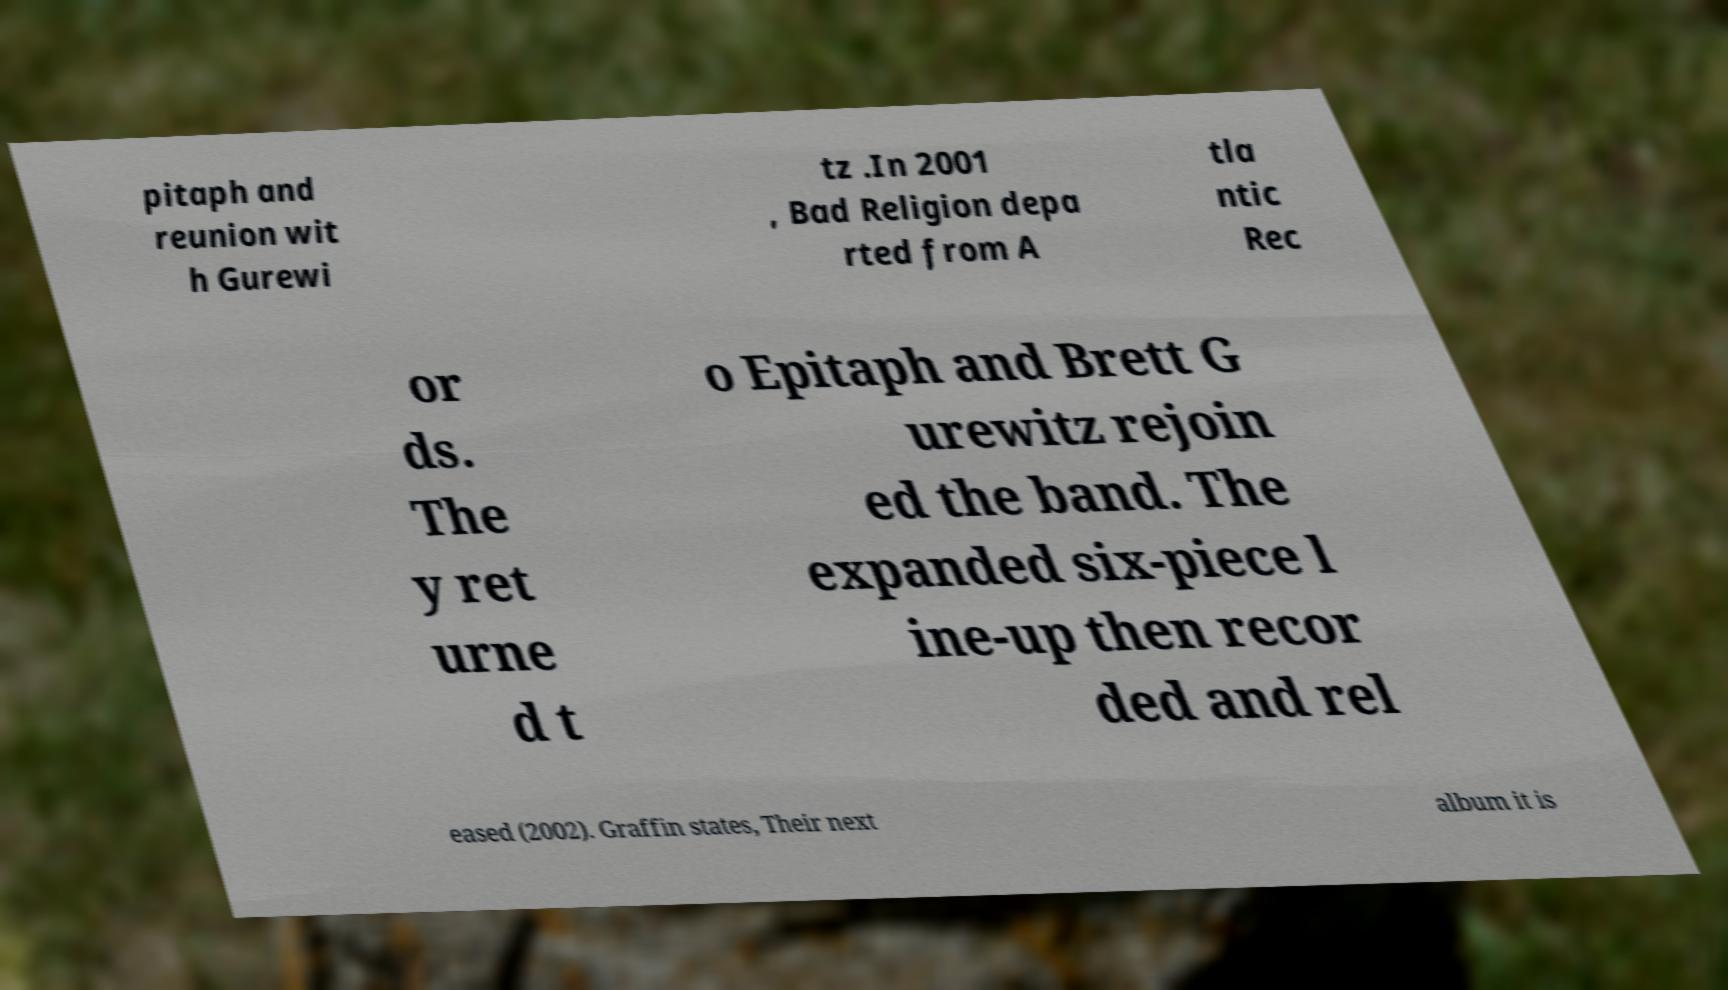Please read and relay the text visible in this image. What does it say? pitaph and reunion wit h Gurewi tz .In 2001 , Bad Religion depa rted from A tla ntic Rec or ds. The y ret urne d t o Epitaph and Brett G urewitz rejoin ed the band. The expanded six-piece l ine-up then recor ded and rel eased (2002). Graffin states, Their next album it is 